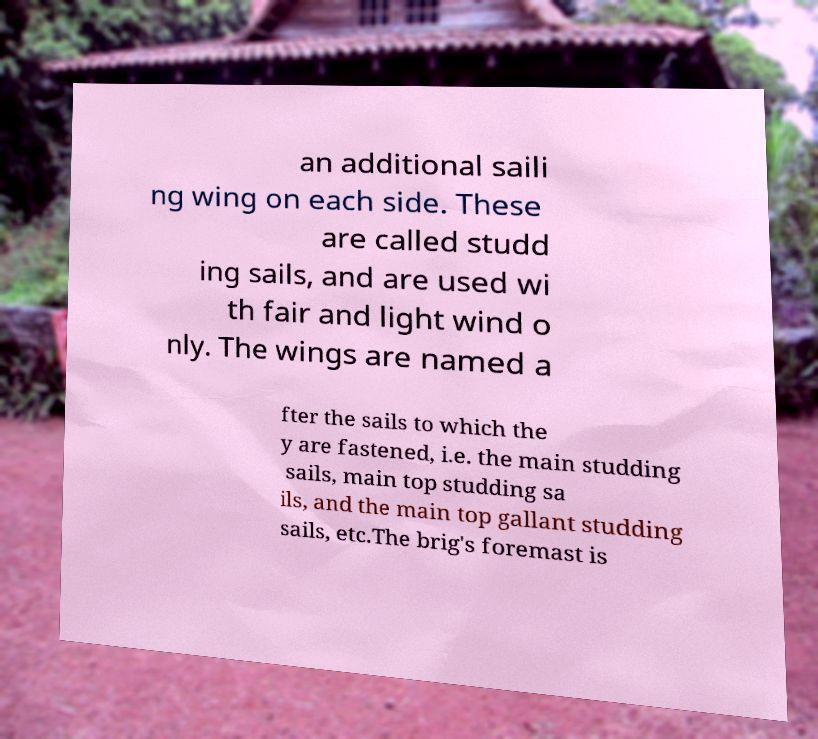Please identify and transcribe the text found in this image. an additional saili ng wing on each side. These are called studd ing sails, and are used wi th fair and light wind o nly. The wings are named a fter the sails to which the y are fastened, i.e. the main studding sails, main top studding sa ils, and the main top gallant studding sails, etc.The brig's foremast is 